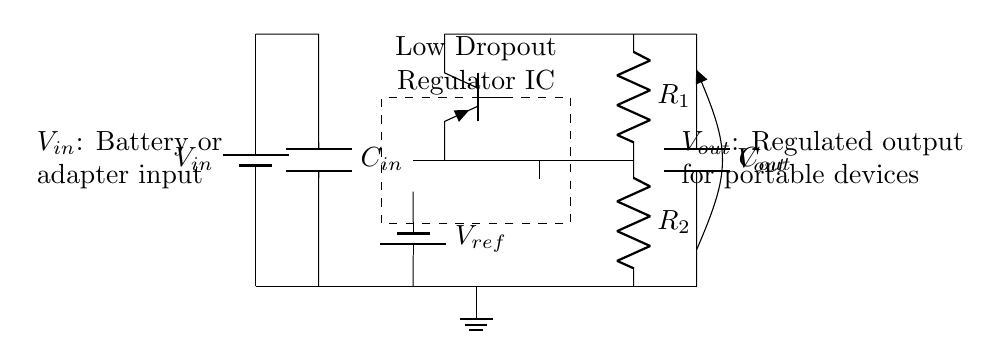What is the input voltage symbol used in the circuit? The symbol used for input voltage in the circuit is V_{in}, indicating the voltage supplied to the regulator.
Answer: V_{in} What type of capacitor is connected to the output? The capacitor connected to the output is labeled C_{out}, indicating it serves the purpose of filtering or stabilizing the output voltage.
Answer: C_{out} What is the function of the component labeled V_{ref}? The component labeled V_{ref} provides a reference voltage to the error amplifier, which is crucial for maintaining the regulated output voltage.
Answer: Reference voltage How many resistors are part of the feedback network? The feedback network comprises two resistors, labeled R_1 and R_2, which are used to set the output voltage by creating a voltage divider.
Answer: Two Why is this circuit referred to as a Low Dropout Regulator? The term "Low Dropout" refers to the ability of the regulator to maintain a stable output voltage even when the input voltage is only slightly higher than the desired output voltage, reducing the dropout voltage.
Answer: Reduced dropout voltage What does the dashed rectangle in the circuit signify? The dashed rectangle signifies the Low Dropout Regulator IC, which contains the key components like the pass transistor and error amplifier to regulate the output voltage.
Answer: Regulator IC What type of transistor is used in the circuit? The transistor used in the circuit is a PNP transistor, indicated by the label Tpnp, which is crucial for the functioning of the regulator.
Answer: PNP transistor 